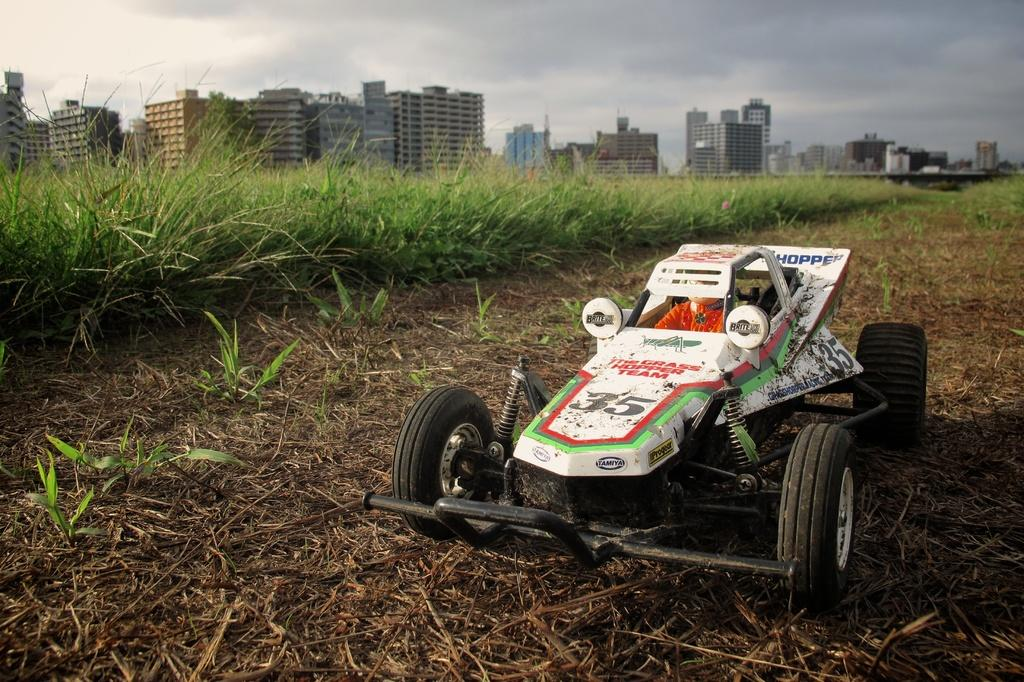What is the person in the image doing? There is a person riding a vehicle in the image. What type of terrain is visible behind the vehicle? There is grass behind the vehicle. What structures can be seen at the top of the image? There are buildings visible at the top of the image. What is visible in the sky at the top of the image? There are clouds in the sky. Can you see the person's sock while they are riding the vehicle in the image? There is no information about the person's sock in the image, so it cannot be determined. Is there a bat flying in the sky in the image? There is no bat visible in the sky in the image. 